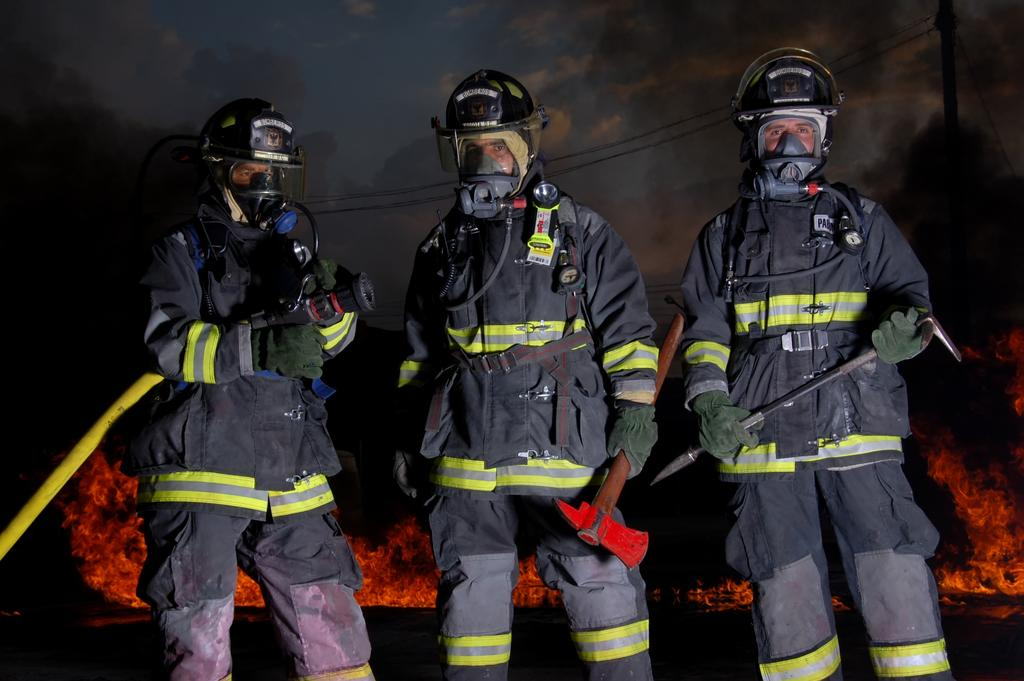How many people are in the image? There are three people in the image. What are the people wearing on their heads? The people are wearing helmets. What are the people holding in their hands? The people are holding objects in their hands. What can be seen in the background of the image? There is fire, a pole, and wires visible in the background. What type of cup is being used to extinguish the fire in the background? There is no cup present in the image, and the fire is not being extinguished. 